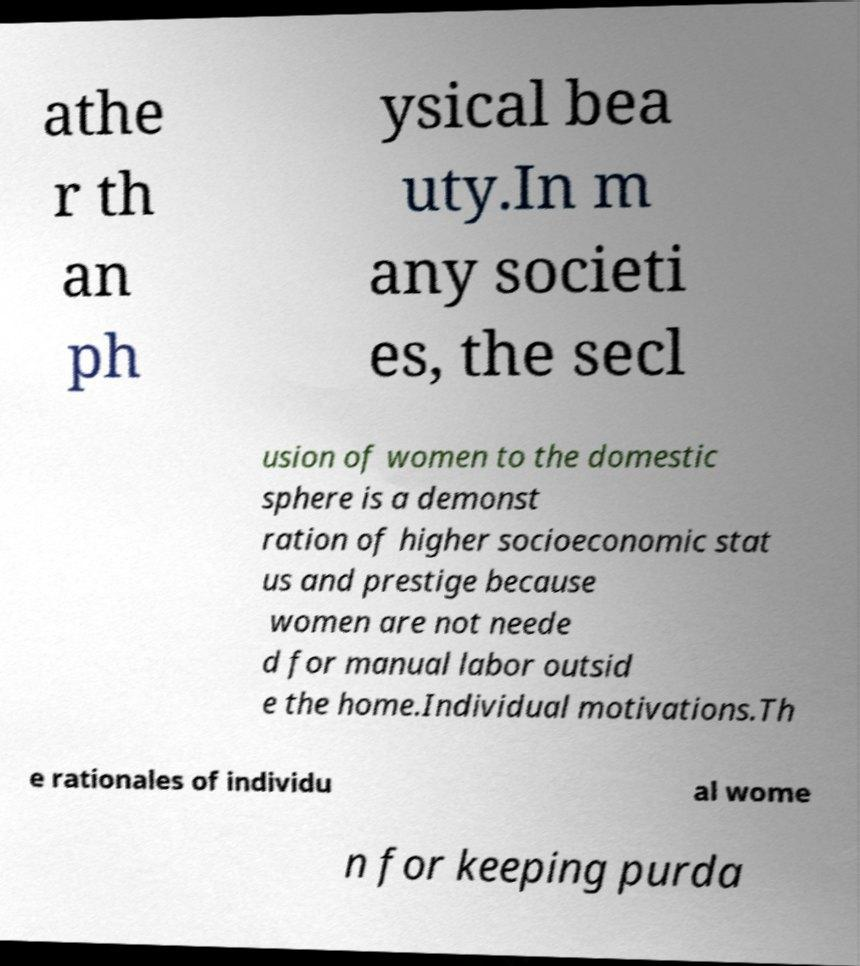Can you accurately transcribe the text from the provided image for me? athe r th an ph ysical bea uty.In m any societi es, the secl usion of women to the domestic sphere is a demonst ration of higher socioeconomic stat us and prestige because women are not neede d for manual labor outsid e the home.Individual motivations.Th e rationales of individu al wome n for keeping purda 